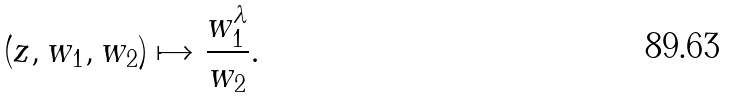Convert formula to latex. <formula><loc_0><loc_0><loc_500><loc_500>( z , w _ { 1 } , w _ { 2 } ) \mapsto \frac { w _ { 1 } ^ { \lambda } } { w _ { 2 } } .</formula> 